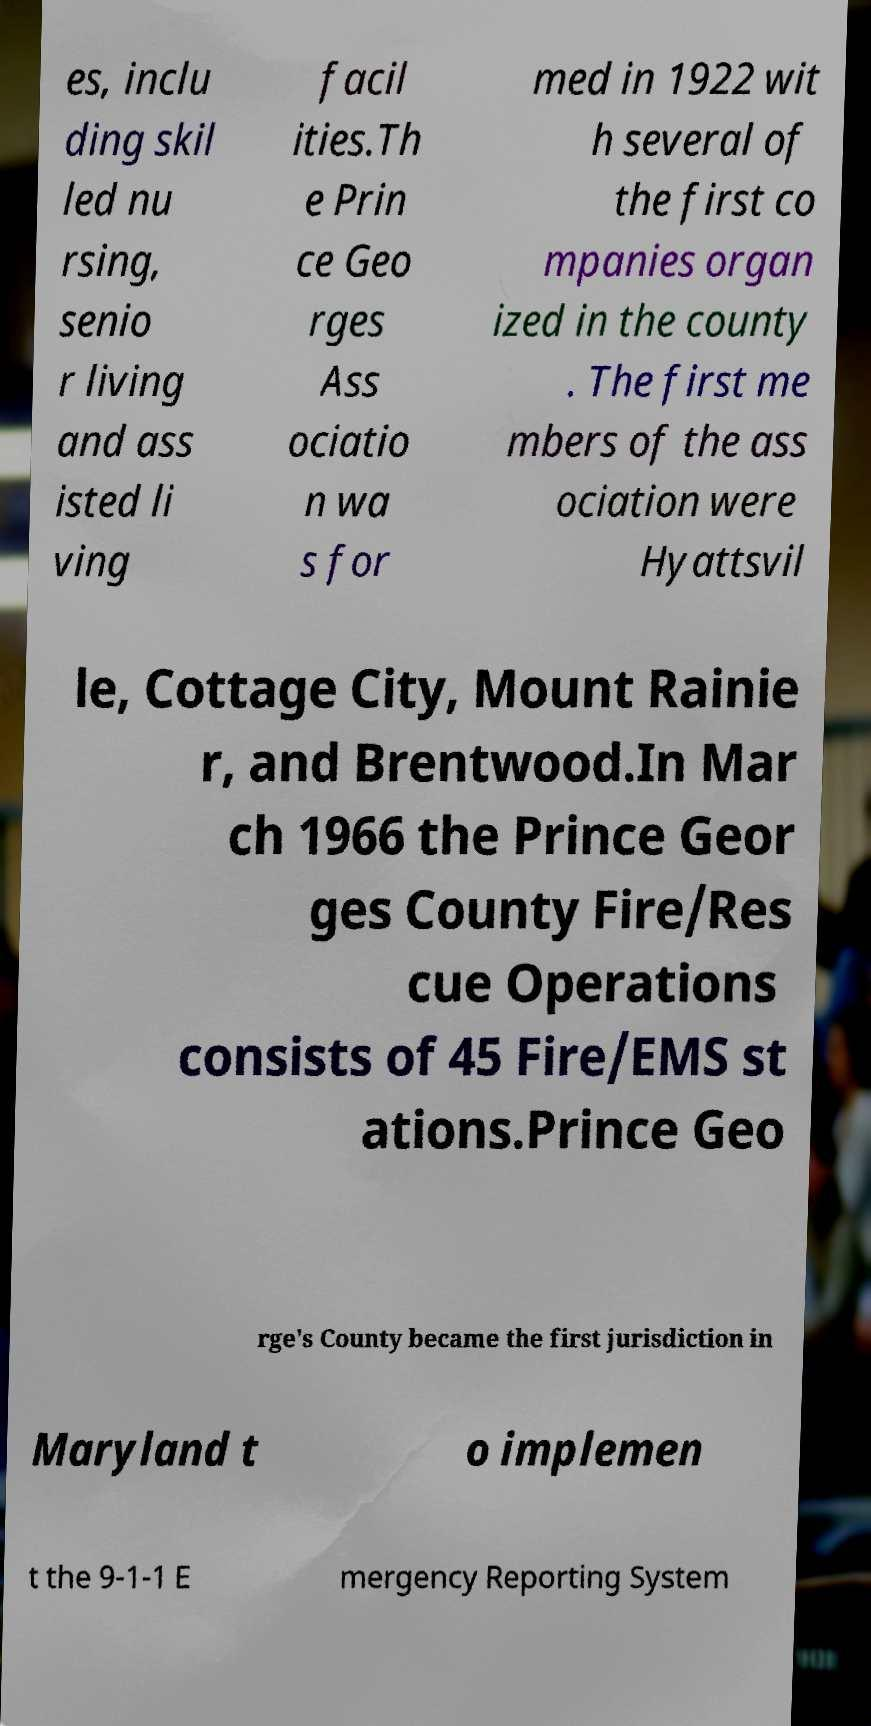For documentation purposes, I need the text within this image transcribed. Could you provide that? es, inclu ding skil led nu rsing, senio r living and ass isted li ving facil ities.Th e Prin ce Geo rges Ass ociatio n wa s for med in 1922 wit h several of the first co mpanies organ ized in the county . The first me mbers of the ass ociation were Hyattsvil le, Cottage City, Mount Rainie r, and Brentwood.In Mar ch 1966 the Prince Geor ges County Fire/Res cue Operations consists of 45 Fire/EMS st ations.Prince Geo rge's County became the first jurisdiction in Maryland t o implemen t the 9-1-1 E mergency Reporting System 